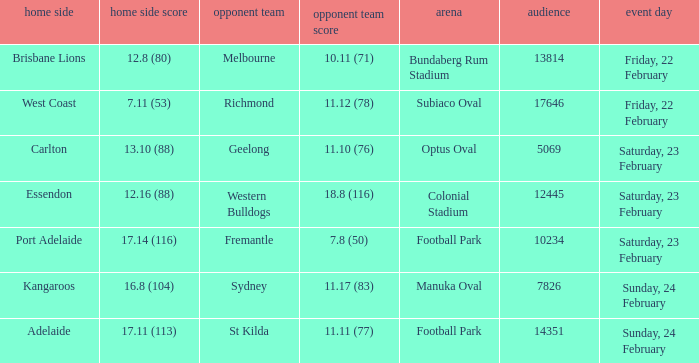Where the home team scored 13.10 (88), what was the size of the crowd? 5069.0. 